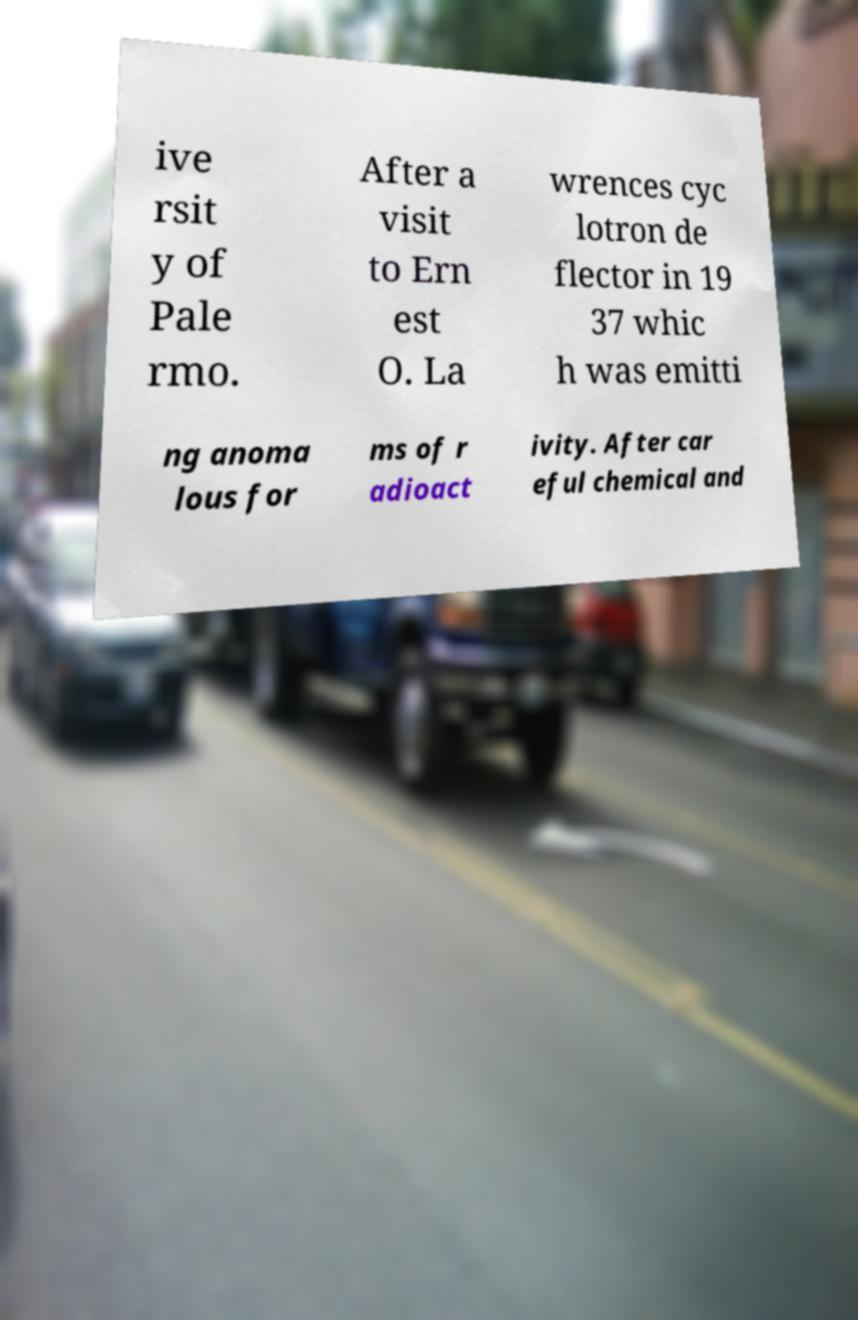Can you accurately transcribe the text from the provided image for me? ive rsit y of Pale rmo. After a visit to Ern est O. La wrences cyc lotron de flector in 19 37 whic h was emitti ng anoma lous for ms of r adioact ivity. After car eful chemical and 